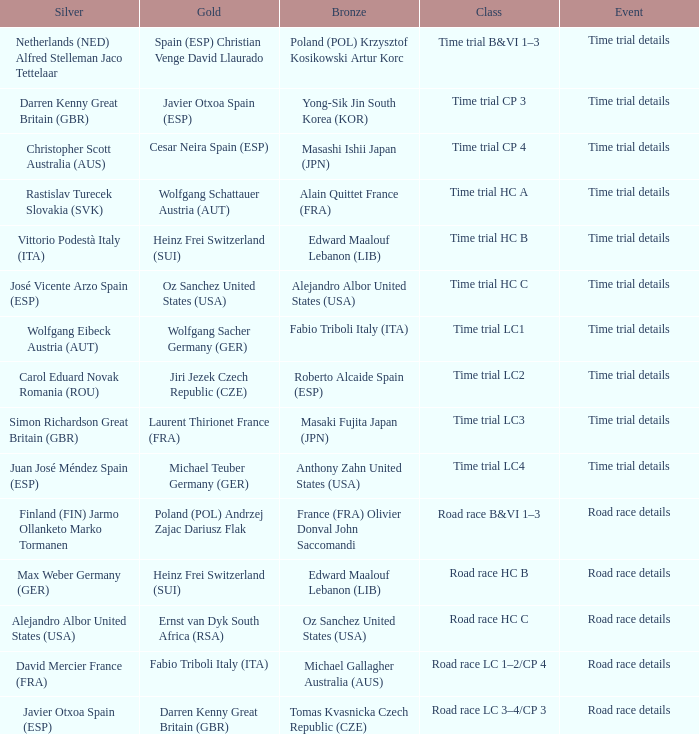What is the event when gold is darren kenny great britain (gbr)? Road race details. 